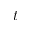<formula> <loc_0><loc_0><loc_500><loc_500>t</formula> 